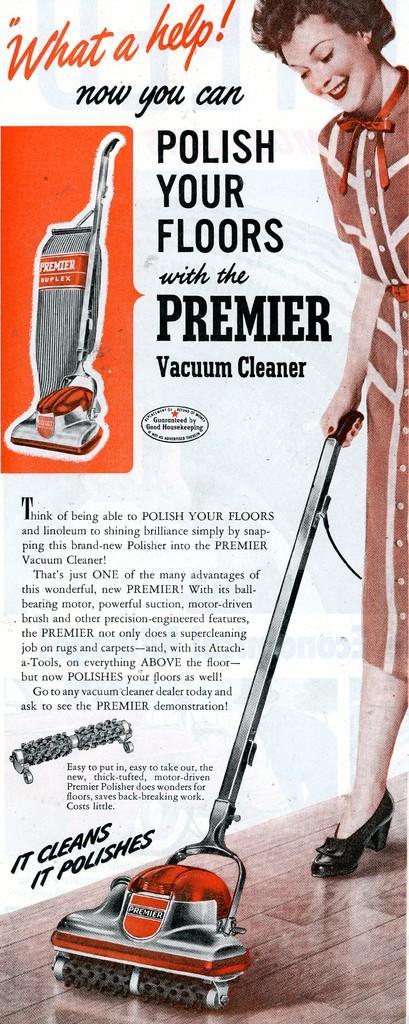Who is the main subject in the image? There is a woman in the image. What is the woman wearing? The woman is wearing a dress. What is the woman doing in the image? The woman is standing on the floor and holding a vacuum cleaner in her hand. What can be seen to the left side of the image? There is some text visible to the left side of the image. Is the woman wearing a mask in the image? There is no mention of a mask in the image, so we cannot determine if the woman is wearing one. How many passengers are visible in the image? There is only one person visible in the image, the woman, so there are no passengers present. 